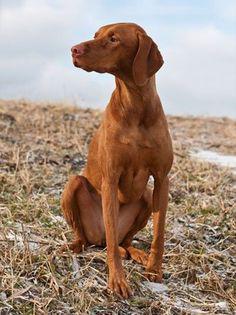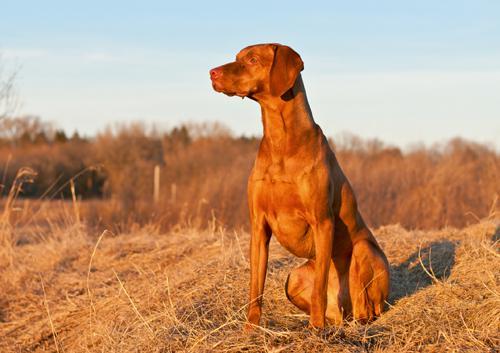The first image is the image on the left, the second image is the image on the right. Considering the images on both sides, is "The dog on the left is looking left and the dog on the right is looking straight ahead." valid? Answer yes or no. No. The first image is the image on the left, the second image is the image on the right. Examine the images to the left and right. Is the description "The left image features a dog with its head turned to the left, and the right image features a dog sitting upright, gazing straight ahead, and wearing a collar with a tag dangling from it." accurate? Answer yes or no. No. 